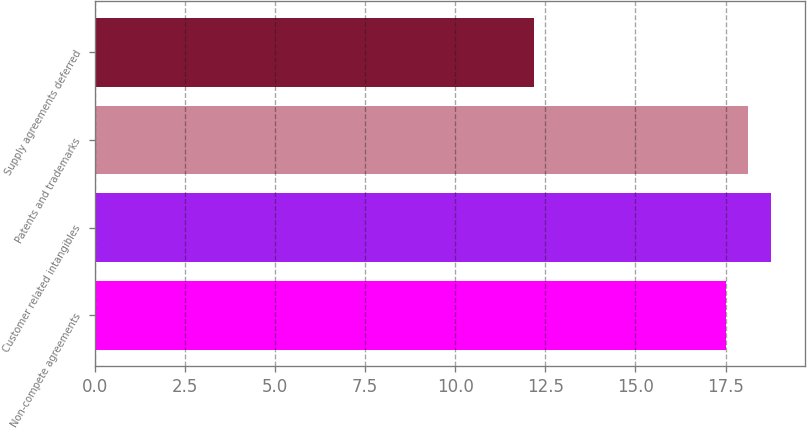<chart> <loc_0><loc_0><loc_500><loc_500><bar_chart><fcel>Non-compete agreements<fcel>Customer related intangibles<fcel>Patents and trademarks<fcel>Supply agreements deferred<nl><fcel>17.5<fcel>18.76<fcel>18.13<fcel>12.2<nl></chart> 